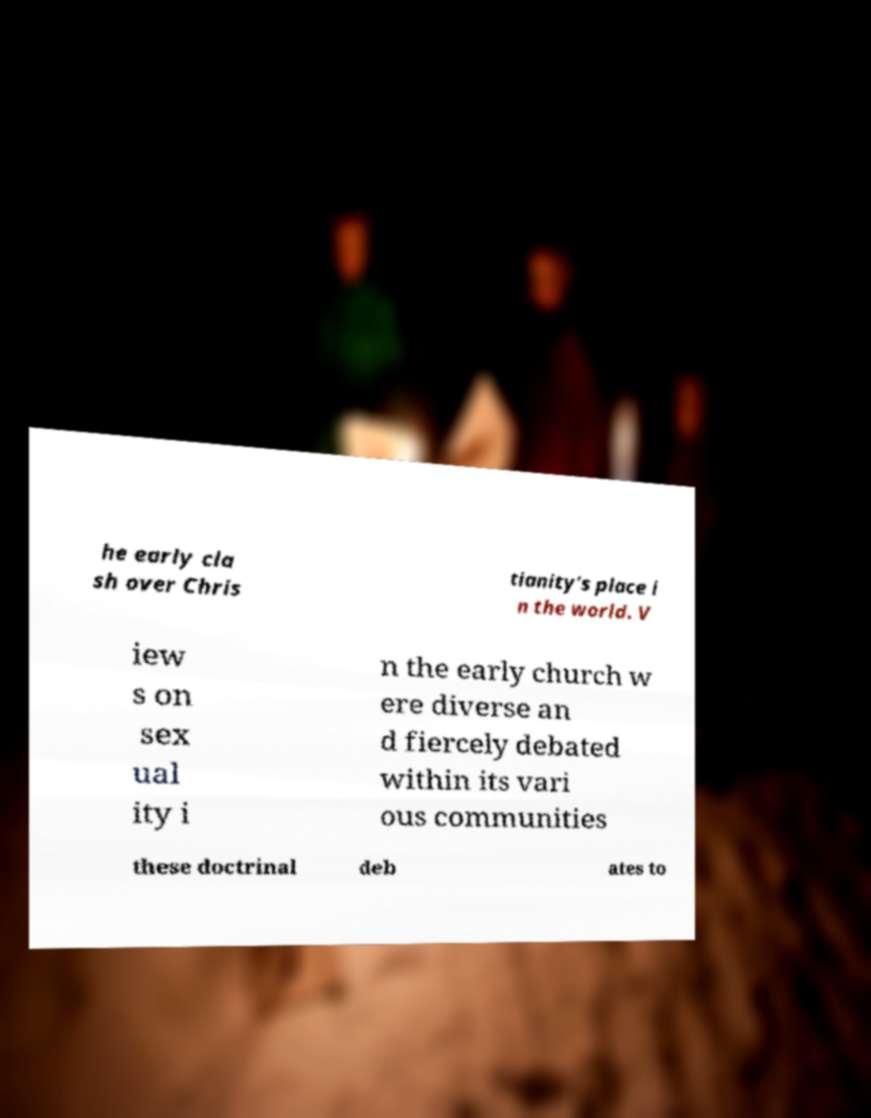Could you extract and type out the text from this image? he early cla sh over Chris tianity's place i n the world. V iew s on sex ual ity i n the early church w ere diverse an d fiercely debated within its vari ous communities these doctrinal deb ates to 